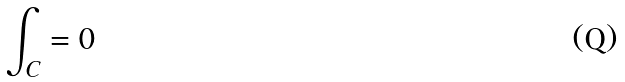<formula> <loc_0><loc_0><loc_500><loc_500>\int _ { C } = 0</formula> 